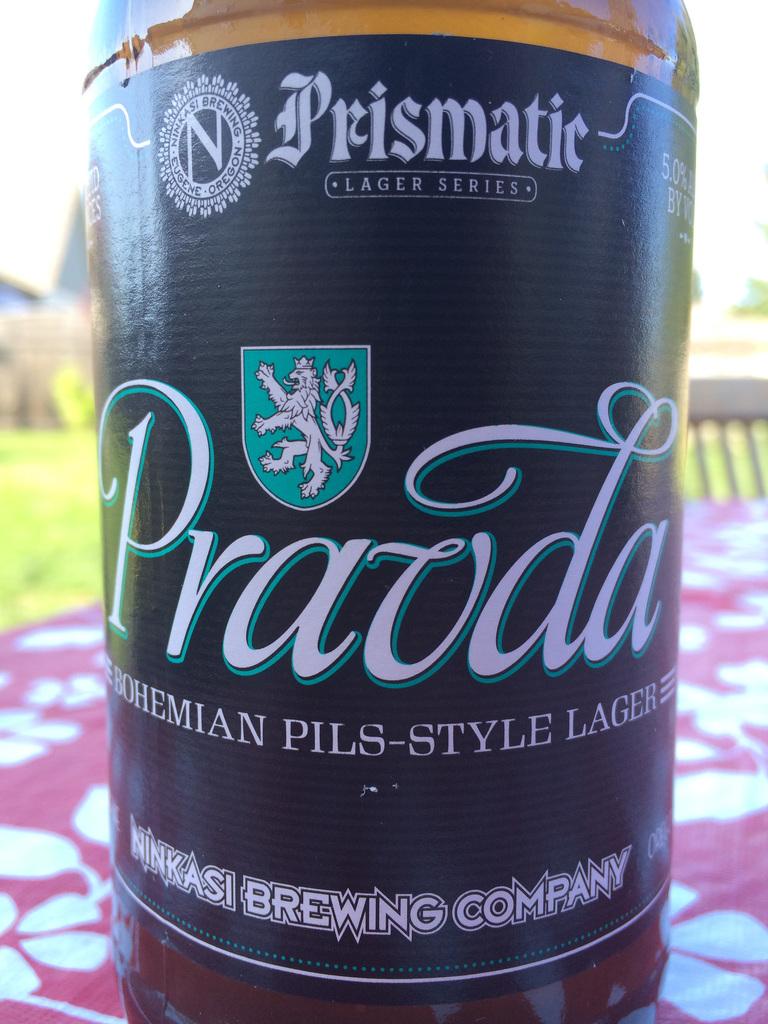What is the brand name?
Provide a short and direct response. Prismatic. What series is this beer?
Your answer should be very brief. Lager. 